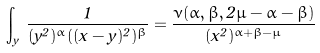<formula> <loc_0><loc_0><loc_500><loc_500>\int _ { y } \, \frac { 1 } { ( y ^ { 2 } ) ^ { \alpha } ( ( x - y ) ^ { 2 } ) ^ { \beta } } = \frac { \nu ( \alpha , \beta , 2 \mu - \alpha - \beta ) } { ( x ^ { 2 } ) ^ { \alpha + \beta - \mu } }</formula> 